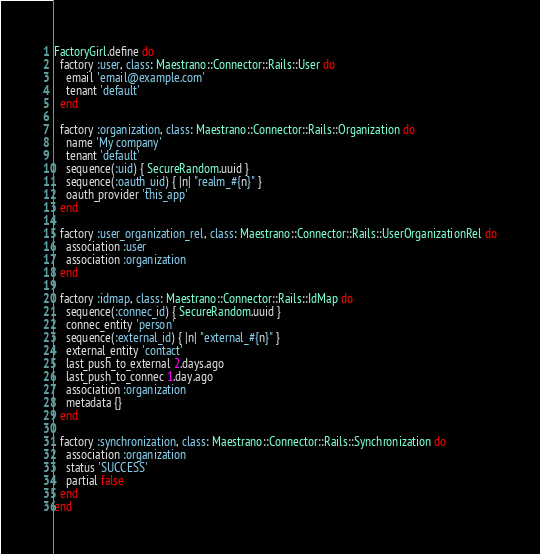<code> <loc_0><loc_0><loc_500><loc_500><_Ruby_>FactoryGirl.define do
  factory :user, class: Maestrano::Connector::Rails::User do
    email 'email@example.com'
    tenant 'default'
  end

  factory :organization, class: Maestrano::Connector::Rails::Organization do
    name 'My company'
    tenant 'default'
    sequence(:uid) { SecureRandom.uuid }
    sequence(:oauth_uid) { |n| "realm_#{n}" }
    oauth_provider 'this_app'
  end

  factory :user_organization_rel, class: Maestrano::Connector::Rails::UserOrganizationRel do
    association :user
    association :organization
  end

  factory :idmap, class: Maestrano::Connector::Rails::IdMap do
    sequence(:connec_id) { SecureRandom.uuid }
    connec_entity 'person'
    sequence(:external_id) { |n| "external_#{n}" }
    external_entity 'contact'
    last_push_to_external 2.days.ago
    last_push_to_connec 1.day.ago
    association :organization
    metadata {}
  end

  factory :synchronization, class: Maestrano::Connector::Rails::Synchronization do
    association :organization
    status 'SUCCESS'
    partial false
  end
end
</code> 